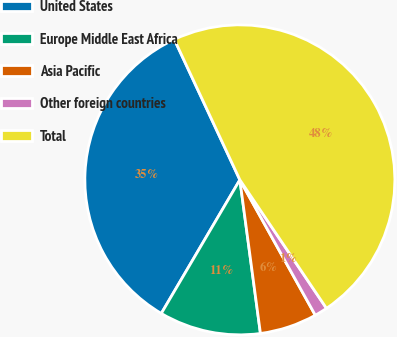Convert chart to OTSL. <chart><loc_0><loc_0><loc_500><loc_500><pie_chart><fcel>United States<fcel>Europe Middle East Africa<fcel>Asia Pacific<fcel>Other foreign countries<fcel>Total<nl><fcel>34.59%<fcel>10.58%<fcel>5.97%<fcel>1.35%<fcel>47.51%<nl></chart> 